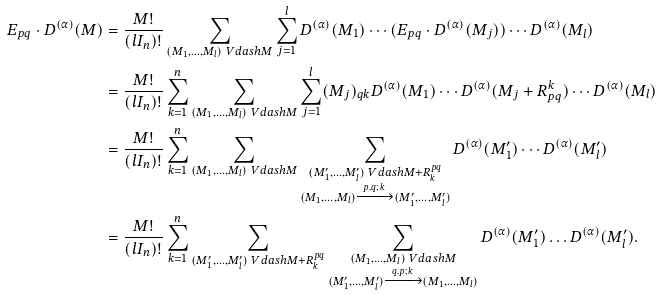Convert formula to latex. <formula><loc_0><loc_0><loc_500><loc_500>E _ { p q } \cdot D ^ { ( \alpha ) } ( M ) & = \frac { M ! } { ( l I _ { n } ) ! } \sum _ { ( M _ { 1 } , \dots , M _ { l } ) \ V d a s h M } \sum _ { j = 1 } ^ { l } D ^ { ( \alpha ) } ( M _ { 1 } ) \cdots ( E _ { p q } \cdot D ^ { ( \alpha ) } ( M _ { j } ) ) \cdots D ^ { ( \alpha ) } ( M _ { l } ) \\ & = \frac { M ! } { ( l I _ { n } ) ! } \sum _ { k = 1 } ^ { n } \sum _ { ( M _ { 1 } , \dots , M _ { l } ) \ V d a s h M } \sum _ { j = 1 } ^ { l } ( M _ { j } ) _ { q k } D ^ { ( \alpha ) } ( M _ { 1 } ) \cdots D ^ { ( \alpha ) } ( M _ { j } + R _ { p q } ^ { k } ) \cdots D ^ { ( \alpha ) } ( M _ { l } ) \\ & = \frac { M ! } { ( l I _ { n } ) ! } \sum _ { k = 1 } ^ { n } \sum _ { ( M _ { 1 } , \dots , M _ { l } ) \ V d a s h M } \sum _ { \substack { ( M _ { 1 } ^ { \prime } , \dots , M _ { l } ^ { \prime } ) \ V d a s h M + R _ { k } ^ { p q } \\ ( M _ { 1 } , \dots , M _ { l } ) \xrightarrow { p , q ; \, k } ( M _ { 1 } ^ { \prime } , \dots , M _ { l } ^ { \prime } ) } } D ^ { ( \alpha ) } ( M _ { 1 } ^ { \prime } ) \cdots D ^ { ( \alpha ) } ( M _ { l } ^ { \prime } ) \\ & = \frac { M ! } { ( l I _ { n } ) ! } \sum _ { k = 1 } ^ { n } \sum _ { ( M _ { 1 } ^ { \prime } , \dots , M _ { l } ^ { \prime } ) \ V d a s h M + R _ { k } ^ { p q } } \sum _ { \substack { ( M _ { 1 } , \dots , M _ { l } ) \ V d a s h M \\ ( M _ { 1 } ^ { \prime } , \dots , M _ { l } ^ { \prime } ) \xrightarrow { q , p ; \, k } ( M _ { 1 } , \dots , M _ { l } ) } } D ^ { ( \alpha ) } ( M _ { 1 } ^ { \prime } ) \dots D ^ { ( \alpha ) } ( M _ { l } ^ { \prime } ) .</formula> 